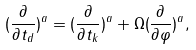Convert formula to latex. <formula><loc_0><loc_0><loc_500><loc_500>( \frac { \partial } { \partial t _ { d } } ) ^ { a } = ( \frac { \partial } { \partial t _ { k } } ) ^ { a } + \Omega ( \frac { \partial } { \partial \varphi } ) ^ { a } ,</formula> 